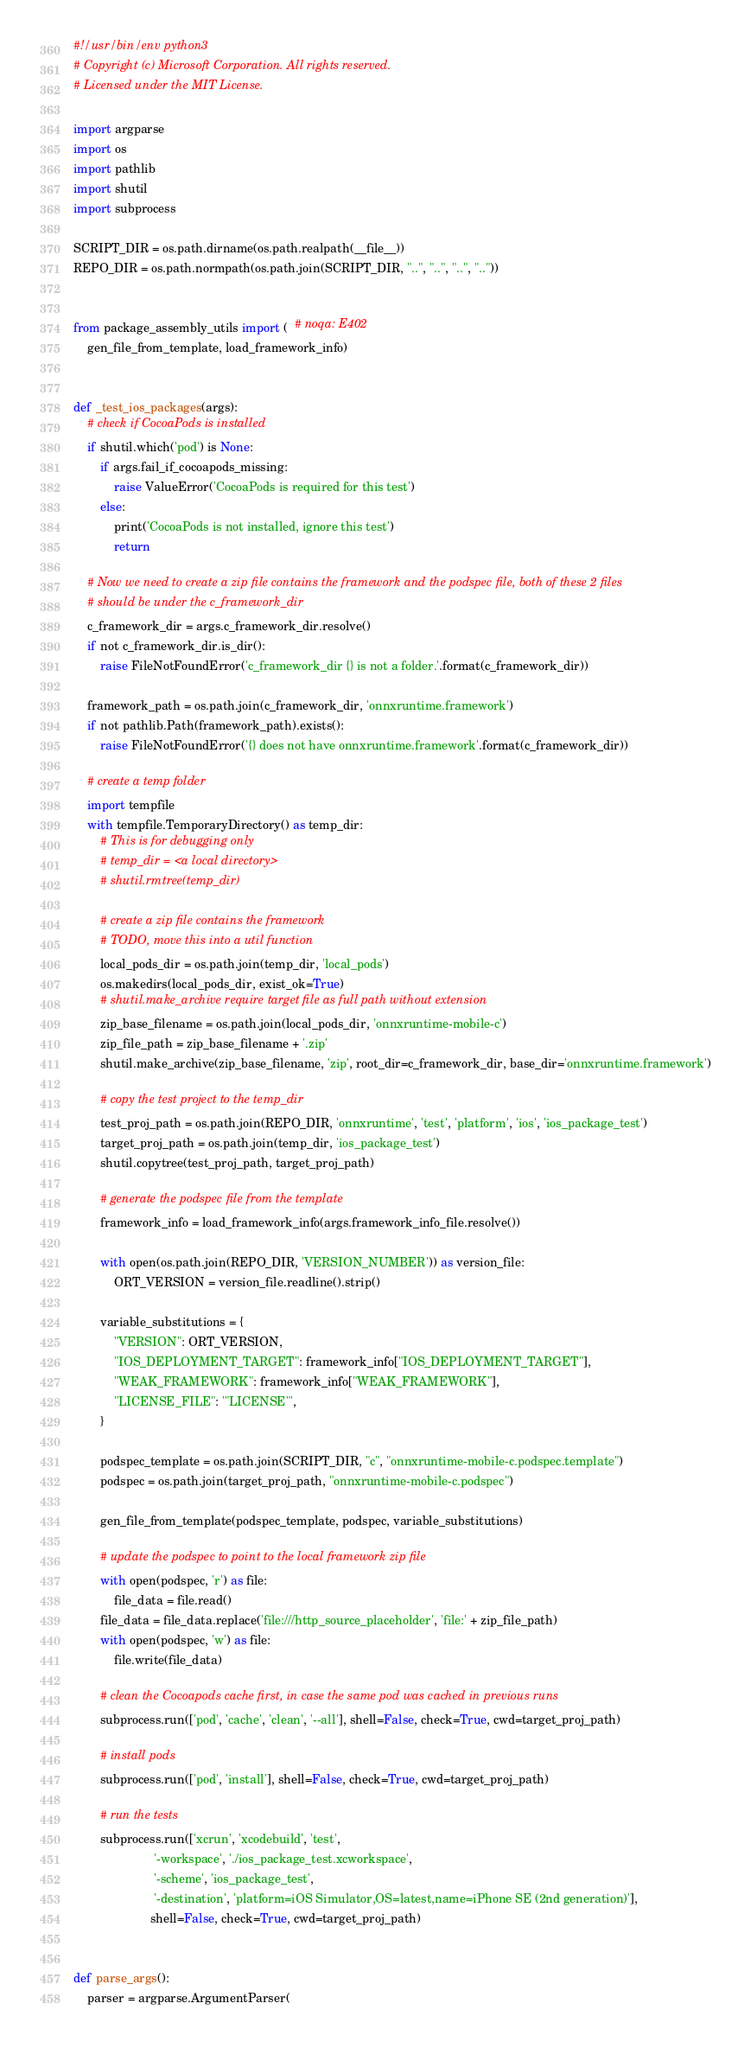<code> <loc_0><loc_0><loc_500><loc_500><_Python_>#!/usr/bin/env python3
# Copyright (c) Microsoft Corporation. All rights reserved.
# Licensed under the MIT License.

import argparse
import os
import pathlib
import shutil
import subprocess

SCRIPT_DIR = os.path.dirname(os.path.realpath(__file__))
REPO_DIR = os.path.normpath(os.path.join(SCRIPT_DIR, "..", "..", "..", ".."))


from package_assembly_utils import (  # noqa: E402
    gen_file_from_template, load_framework_info)


def _test_ios_packages(args):
    # check if CocoaPods is installed
    if shutil.which('pod') is None:
        if args.fail_if_cocoapods_missing:
            raise ValueError('CocoaPods is required for this test')
        else:
            print('CocoaPods is not installed, ignore this test')
            return

    # Now we need to create a zip file contains the framework and the podspec file, both of these 2 files
    # should be under the c_framework_dir
    c_framework_dir = args.c_framework_dir.resolve()
    if not c_framework_dir.is_dir():
        raise FileNotFoundError('c_framework_dir {} is not a folder.'.format(c_framework_dir))

    framework_path = os.path.join(c_framework_dir, 'onnxruntime.framework')
    if not pathlib.Path(framework_path).exists():
        raise FileNotFoundError('{} does not have onnxruntime.framework'.format(c_framework_dir))

    # create a temp folder
    import tempfile
    with tempfile.TemporaryDirectory() as temp_dir:
        # This is for debugging only
        # temp_dir = <a local directory>
        # shutil.rmtree(temp_dir)

        # create a zip file contains the framework
        # TODO, move this into a util function
        local_pods_dir = os.path.join(temp_dir, 'local_pods')
        os.makedirs(local_pods_dir, exist_ok=True)
        # shutil.make_archive require target file as full path without extension
        zip_base_filename = os.path.join(local_pods_dir, 'onnxruntime-mobile-c')
        zip_file_path = zip_base_filename + '.zip'
        shutil.make_archive(zip_base_filename, 'zip', root_dir=c_framework_dir, base_dir='onnxruntime.framework')

        # copy the test project to the temp_dir
        test_proj_path = os.path.join(REPO_DIR, 'onnxruntime', 'test', 'platform', 'ios', 'ios_package_test')
        target_proj_path = os.path.join(temp_dir, 'ios_package_test')
        shutil.copytree(test_proj_path, target_proj_path)

        # generate the podspec file from the template
        framework_info = load_framework_info(args.framework_info_file.resolve())

        with open(os.path.join(REPO_DIR, 'VERSION_NUMBER')) as version_file:
            ORT_VERSION = version_file.readline().strip()

        variable_substitutions = {
            "VERSION": ORT_VERSION,
            "IOS_DEPLOYMENT_TARGET": framework_info["IOS_DEPLOYMENT_TARGET"],
            "WEAK_FRAMEWORK": framework_info["WEAK_FRAMEWORK"],
            "LICENSE_FILE": '"LICENSE"',
        }

        podspec_template = os.path.join(SCRIPT_DIR, "c", "onnxruntime-mobile-c.podspec.template")
        podspec = os.path.join(target_proj_path, "onnxruntime-mobile-c.podspec")

        gen_file_from_template(podspec_template, podspec, variable_substitutions)

        # update the podspec to point to the local framework zip file
        with open(podspec, 'r') as file:
            file_data = file.read()
        file_data = file_data.replace('file:///http_source_placeholder', 'file:' + zip_file_path)
        with open(podspec, 'w') as file:
            file.write(file_data)

        # clean the Cocoapods cache first, in case the same pod was cached in previous runs
        subprocess.run(['pod', 'cache', 'clean', '--all'], shell=False, check=True, cwd=target_proj_path)

        # install pods
        subprocess.run(['pod', 'install'], shell=False, check=True, cwd=target_proj_path)

        # run the tests
        subprocess.run(['xcrun', 'xcodebuild', 'test',
                        '-workspace', './ios_package_test.xcworkspace',
                        '-scheme', 'ios_package_test',
                        '-destination', 'platform=iOS Simulator,OS=latest,name=iPhone SE (2nd generation)'],
                       shell=False, check=True, cwd=target_proj_path)


def parse_args():
    parser = argparse.ArgumentParser(</code> 